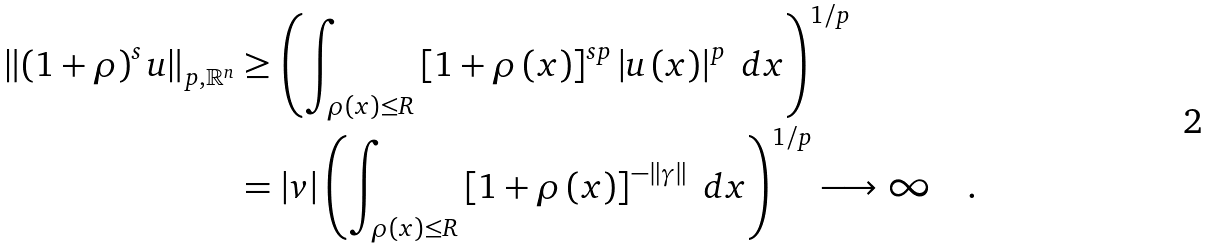<formula> <loc_0><loc_0><loc_500><loc_500>\left \| \left ( 1 + \rho \right ) ^ { s } u \right \| _ { p , \mathbb { R } ^ { n } } & \geq \left ( \int _ { \rho \left ( x \right ) \leq R } \left [ 1 + \rho \left ( x \right ) \right ] ^ { s p } \left | u \left ( x \right ) \right | ^ { p } \ d x \right ) ^ { 1 / p } \\ & = \left | v \right | \left ( \int _ { \rho \left ( x \right ) \leq R } \left [ 1 + \rho \left ( x \right ) \right ] ^ { - \left \| \gamma \right \| } \ d x \right ) ^ { 1 / p } \longrightarrow \infty \quad .</formula> 